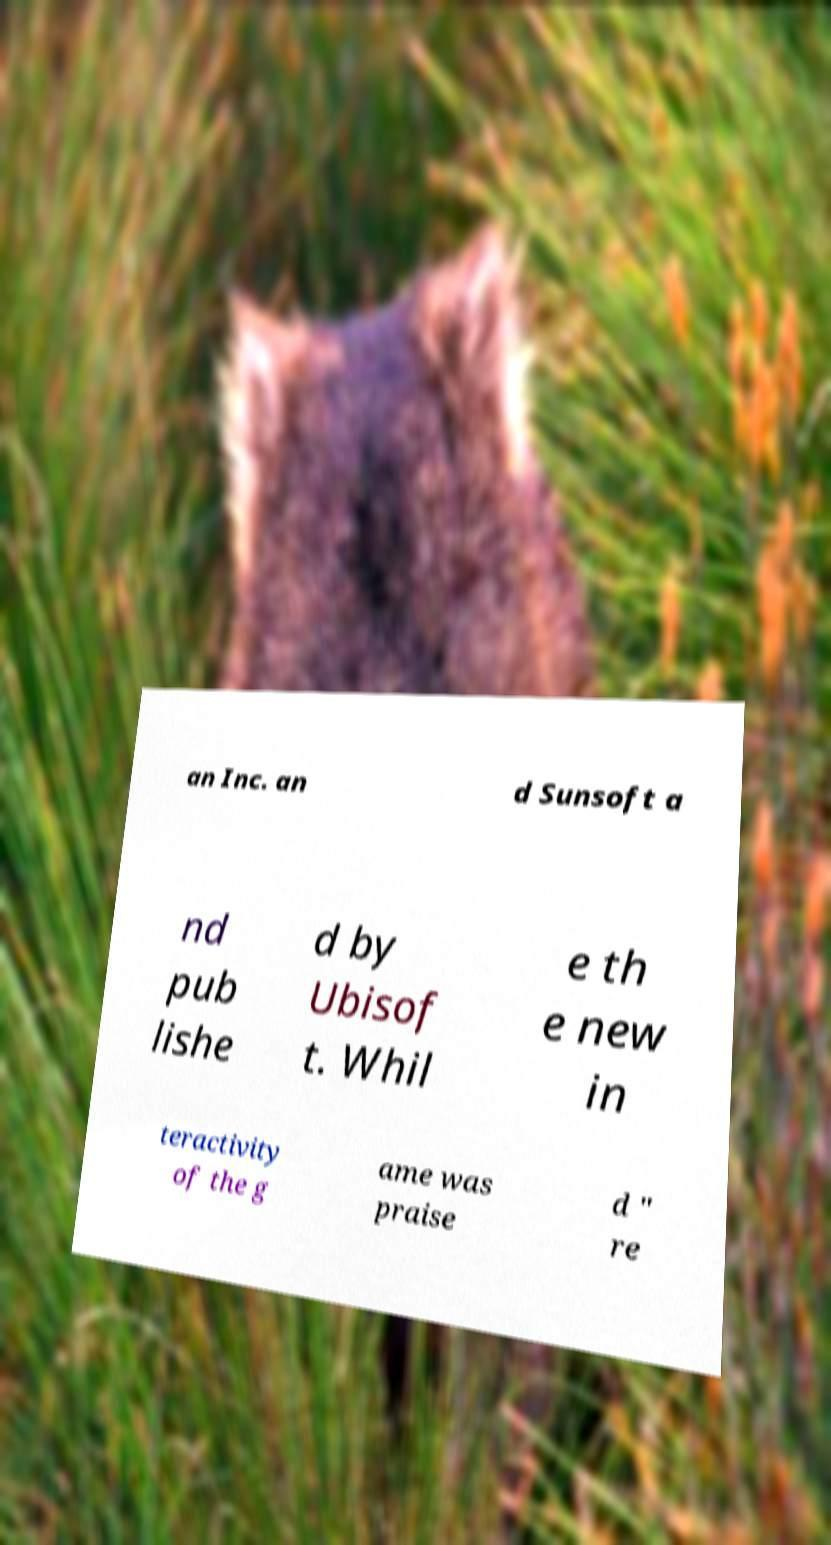Can you accurately transcribe the text from the provided image for me? an Inc. an d Sunsoft a nd pub lishe d by Ubisof t. Whil e th e new in teractivity of the g ame was praise d " re 